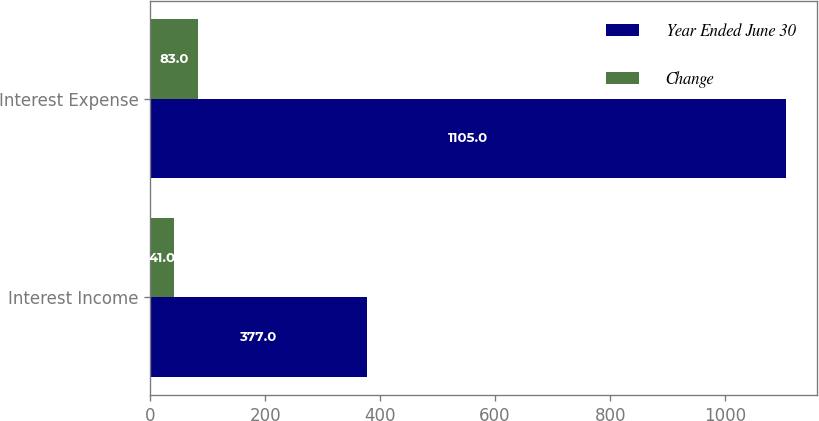Convert chart. <chart><loc_0><loc_0><loc_500><loc_500><stacked_bar_chart><ecel><fcel>Interest Income<fcel>Interest Expense<nl><fcel>Year Ended June 30<fcel>377<fcel>1105<nl><fcel>Change<fcel>41<fcel>83<nl></chart> 